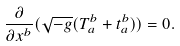Convert formula to latex. <formula><loc_0><loc_0><loc_500><loc_500>\frac { \partial } { \partial x ^ { b } } ( \sqrt { - g } ( T ^ { b } _ { a } + t ^ { b } _ { a } ) ) = 0 .</formula> 